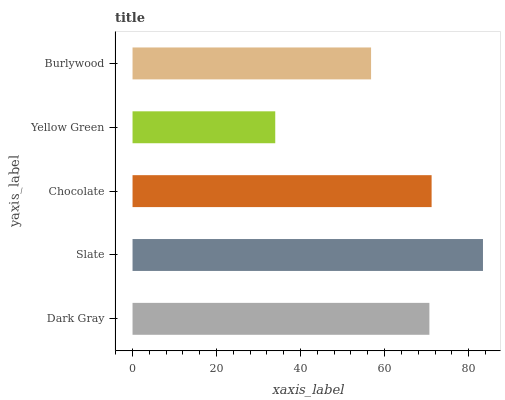Is Yellow Green the minimum?
Answer yes or no. Yes. Is Slate the maximum?
Answer yes or no. Yes. Is Chocolate the minimum?
Answer yes or no. No. Is Chocolate the maximum?
Answer yes or no. No. Is Slate greater than Chocolate?
Answer yes or no. Yes. Is Chocolate less than Slate?
Answer yes or no. Yes. Is Chocolate greater than Slate?
Answer yes or no. No. Is Slate less than Chocolate?
Answer yes or no. No. Is Dark Gray the high median?
Answer yes or no. Yes. Is Dark Gray the low median?
Answer yes or no. Yes. Is Chocolate the high median?
Answer yes or no. No. Is Chocolate the low median?
Answer yes or no. No. 